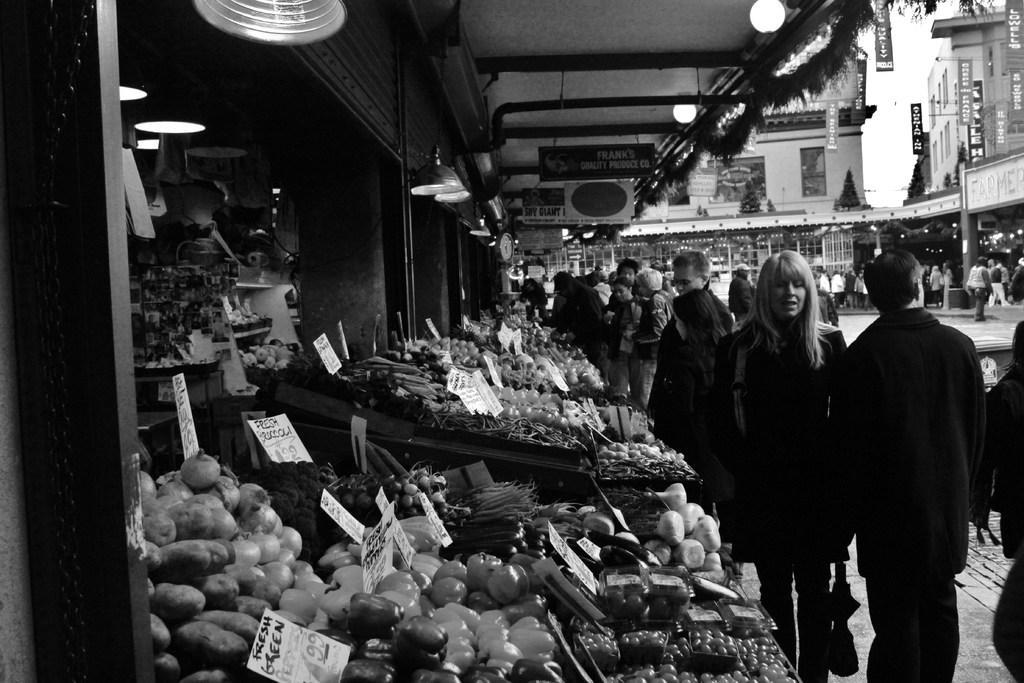Can you describe this image briefly? In this image, we can see few shops. Here we can see eatable things, vegetables, name boards. Right side of the image, we can see a group of people are standing. Few are holding some objects. Top of the image, we can see few buildings, banners, hoardings and lights. 